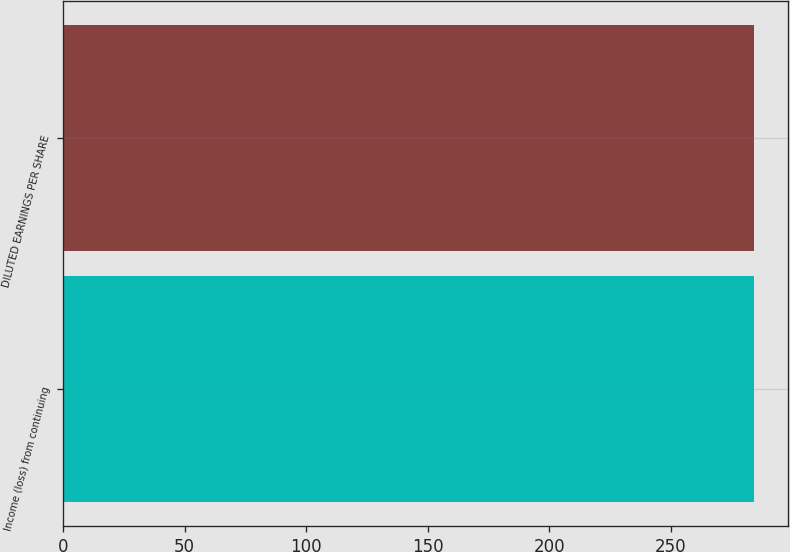Convert chart. <chart><loc_0><loc_0><loc_500><loc_500><bar_chart><fcel>Income (loss) from continuing<fcel>DILUTED EARNINGS PER SHARE<nl><fcel>284<fcel>284.1<nl></chart> 